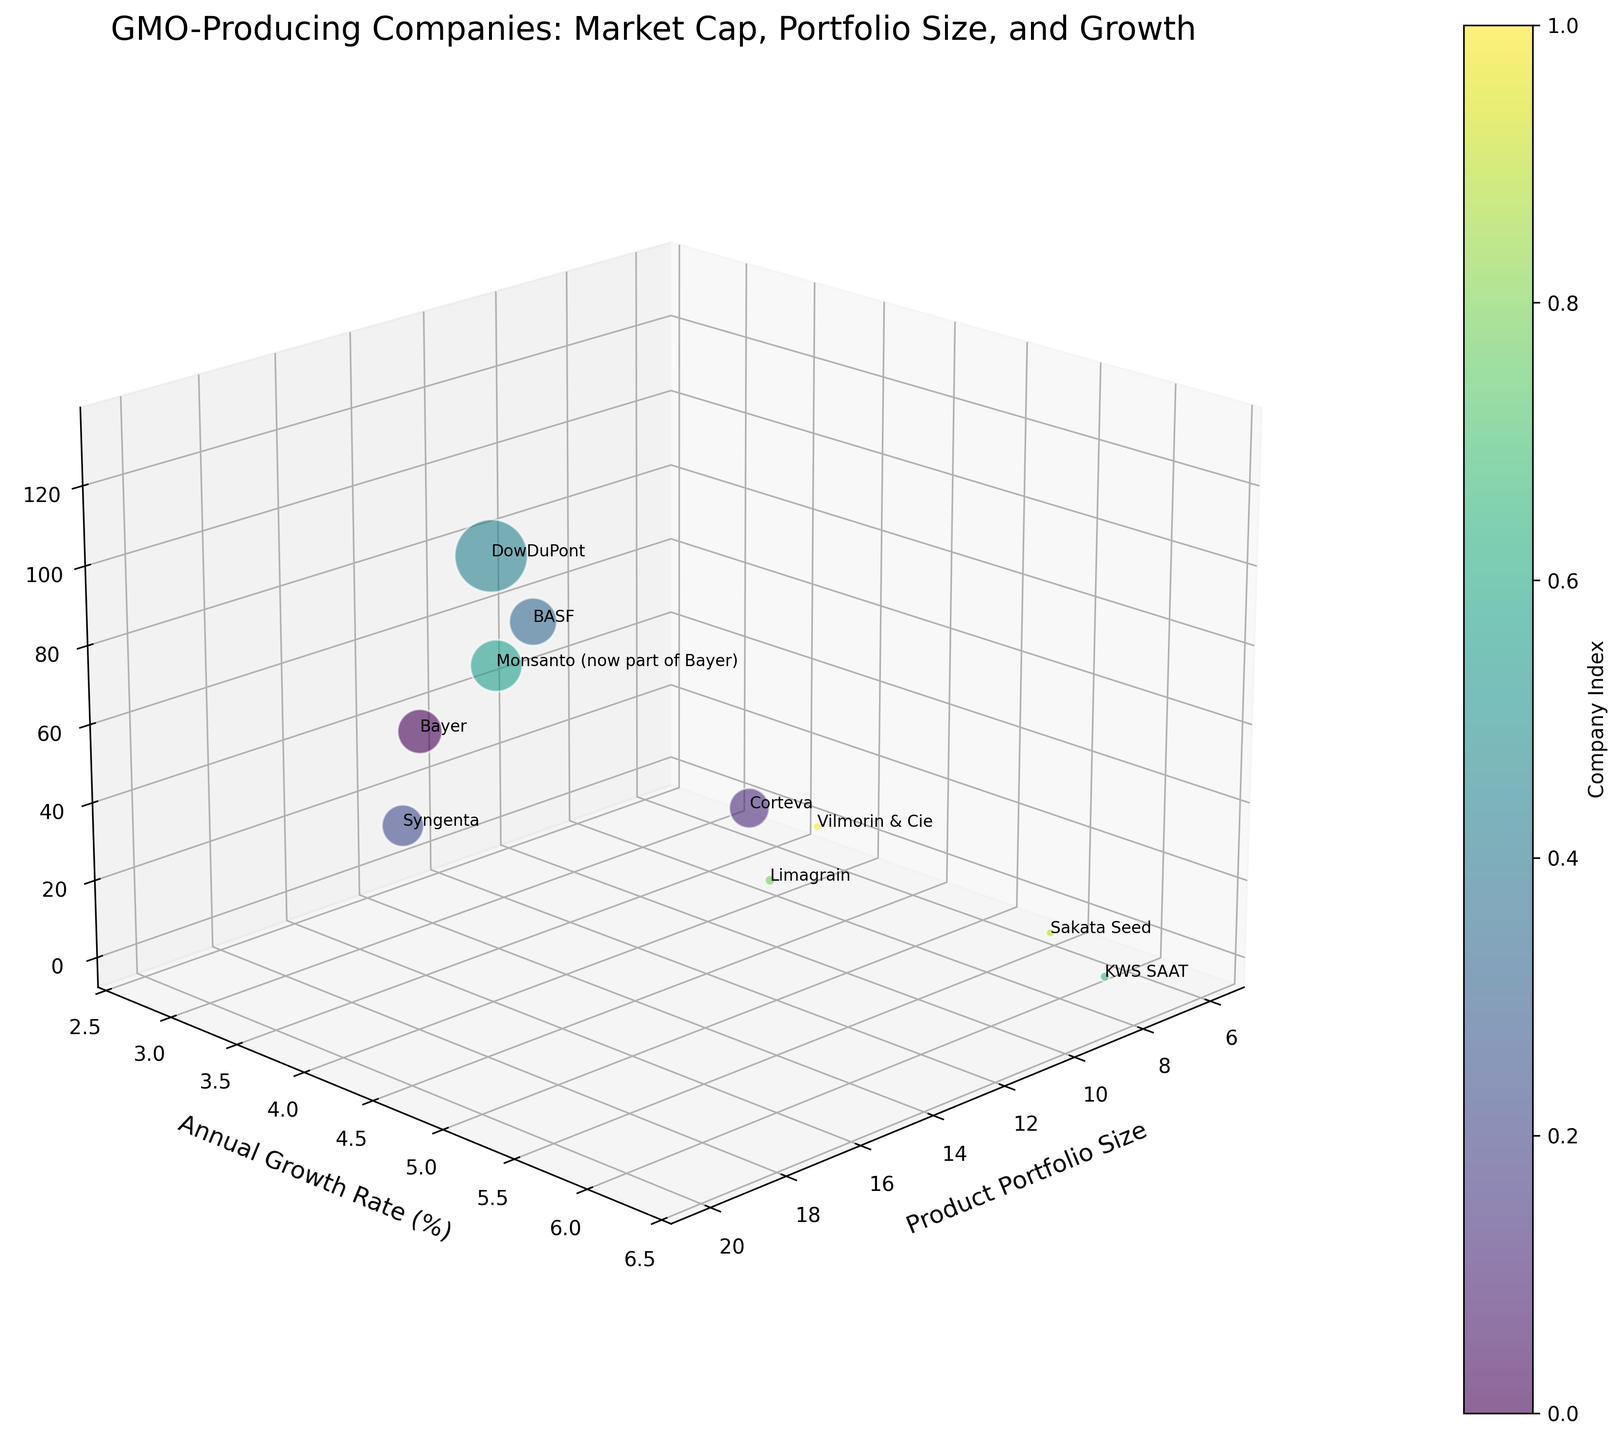What's the title of the plot? The title is displayed at the top of the plot and gives a summary of what the plot represents.
Answer: GMO-Producing Companies: Market Cap, Portfolio Size, and Growth How many companies are represented in the plot? Count the number of distinct bubbles or annotations in the plot.
Answer: 10 Which company has the highest market capitalization? Identify the tallest bubble or the bubble with the highest value on the z-axis and refer to the annotation.
Answer: DowDuPont Which company has the smallest product portfolio size? Identify the bubble with the smallest value on the x-axis and refer to the annotation.
Answer: Vilmorin & Cie What is the market cap of Corteva, and what does this tell you about its position relative to other companies? Find the bubble annotated as 'Corteva' and note its position on the z-axis relative to other bubbles.
Answer: 39.2 Billion USD, it is mid-range compared to other companies Which company shows the highest annual growth rate? Identify the bubble with the highest value on the y-axis and refer to the annotation.
Answer: KWS SAAT Compare the annual growth rates of Bayer and Monsanto. Locate the bubbles for Bayer and Monsanto on the y-axis and compare their values.
Answer: Bayer: 3.2%, Monsanto: 3.5% What can be inferred about BASF's market strategy based on its market cap and product portfolio size? Locate BASF's bubble and interpret its position on the x-axis (product portfolio size) and z-axis (market cap).
Answer: BASF has a high market cap and a relatively small product portfolio, indicating a focus on fewer but possibly high-value or heavily invested products Is there a company with both a high product portfolio size and a high annual growth rate? If yes, which one? Look for bubbles that are positioned high on both the x-axis and y-axis. Compare annotations.
Answer: DowDuPont Identify the companies with a market cap below 10 billion USD. Locate all bubbles with values less than 10 on the z-axis and refer to their annotations.
Answer: KWS SAAT, Limagrain, Sakata Seed, Vilmorin & Cie 